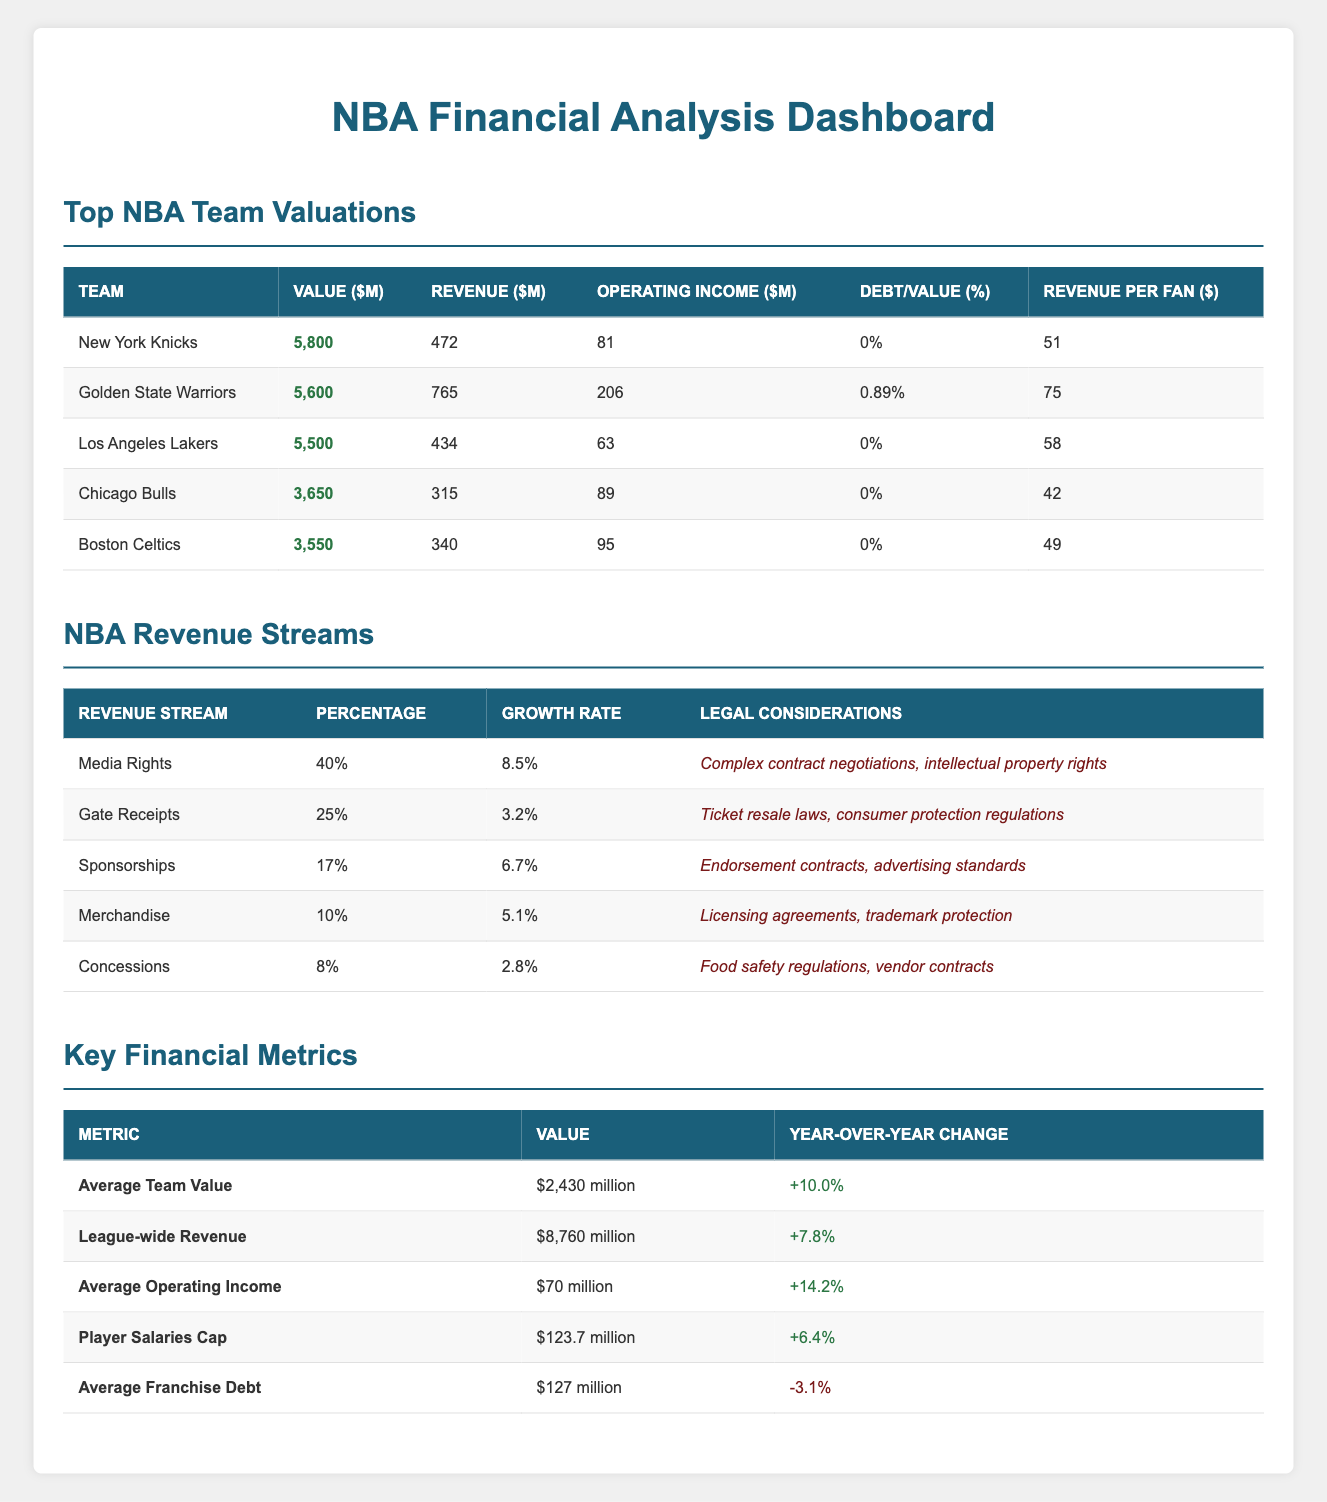What is the operating income of the Chicago Bulls? The table indicates that the Chicago Bulls have an operating income listed as 89 million USD.
Answer: 89 million USD Which team has the highest debt value, and what is that amount? From the table, we can see that the only team with a debt value is the Golden State Warriors, which has a debt value of 50 million USD.
Answer: Golden State Warriors; 50 million USD What is the average revenue per fan for the Los Angeles Lakers? The revenue per fan for the Los Angeles Lakers is listed as 58 USD in the table.
Answer: 58 USD What is the total revenue of all five teams combined? To find the total revenue, we add the revenues: 472 + 765 + 434 + 315 + 340 = 2326 million USD.
Answer: 2326 million USD Is the average franchise debt increasing or decreasing? The table shows that the average franchise debt has a year-over-year change of -3.1%, indicating it is decreasing.
Answer: Decreasing Which revenue stream accounts for the highest percentage of total revenue? The highest percentage in revenue streams is 40% from Media Rights as shown in the table.
Answer: Media Rights; 40% What is the growth rate of the sponsorships revenue stream? In the revenue streams table, the growth rate for sponsorships is listed as 6.7%.
Answer: 6.7% If the average team value increased by 10% from last year, what was the average team value last year? The average team value this year is 2430 million USD, and to find last year's value, we set up the equation: Last year's average value * 1.10 = 2430 million USD, which means Last year's average value = 2430/1.10 ≈ 2209.09 million USD.
Answer: Approximately 2209.09 million USD What percentage of the NBA's league-wide revenue comes from concessions? The table shows that concessions account for 8% of the total league-wide revenue.
Answer: 8% 